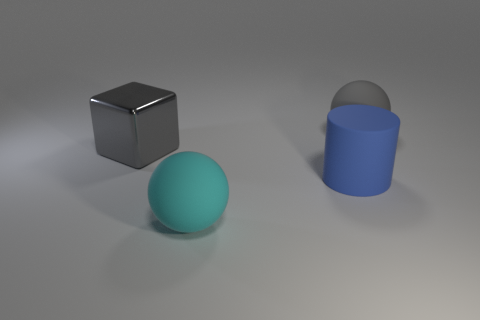Can you suggest what materials these objects might be made from based on their surfaces? The cube appears to have a metallic surface because of its high reflectivity, while the sphere and cylinder look like they could be made of matte plastic due to their diffuse reflection. 